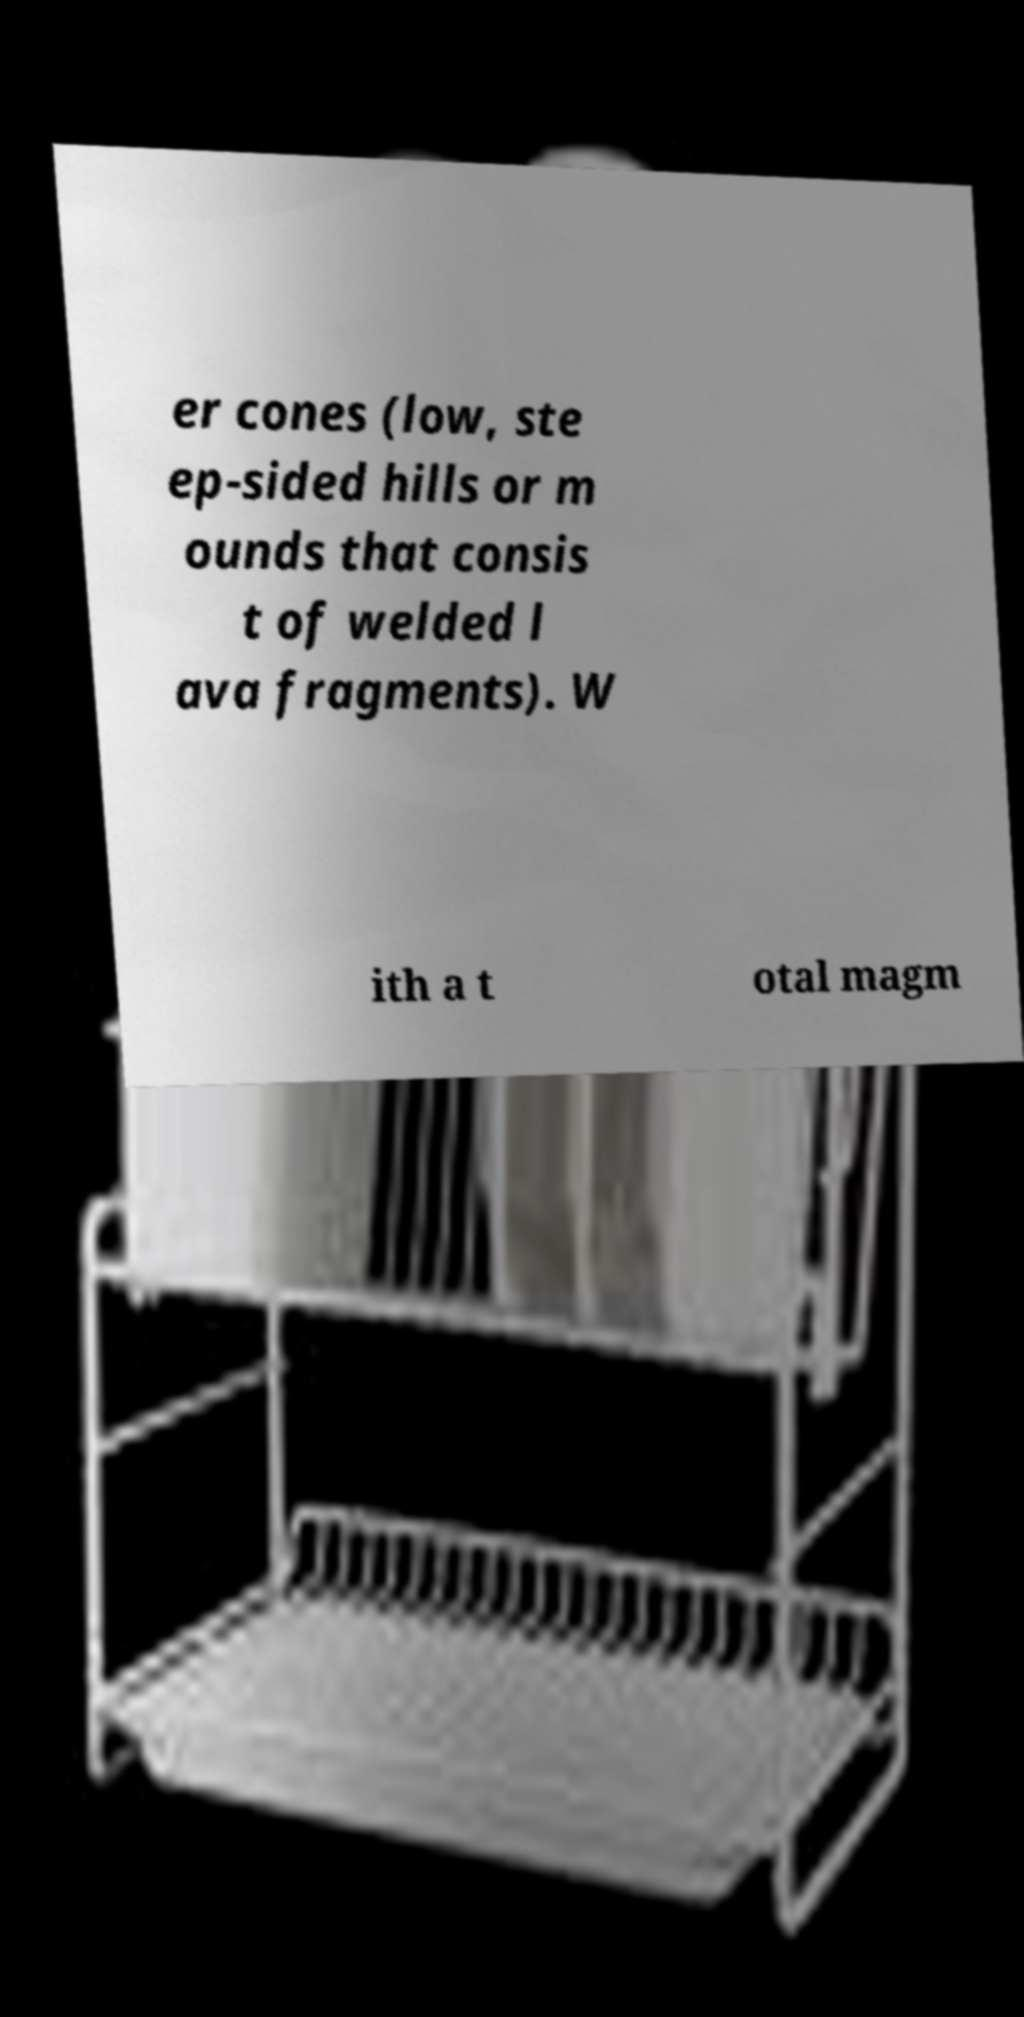There's text embedded in this image that I need extracted. Can you transcribe it verbatim? er cones (low, ste ep-sided hills or m ounds that consis t of welded l ava fragments). W ith a t otal magm 